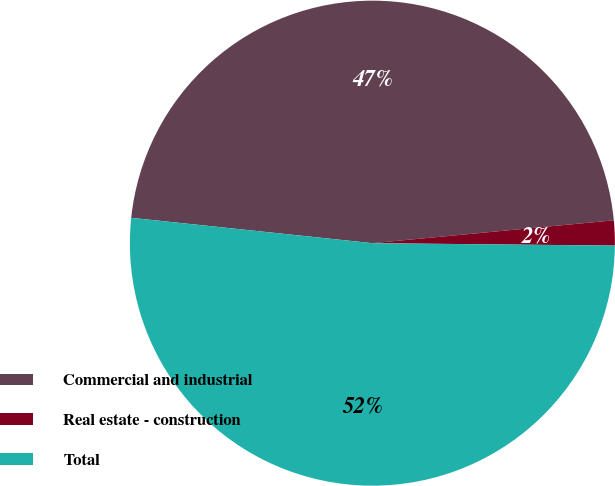Convert chart. <chart><loc_0><loc_0><loc_500><loc_500><pie_chart><fcel>Commercial and industrial<fcel>Real estate - construction<fcel>Total<nl><fcel>46.83%<fcel>1.66%<fcel>51.51%<nl></chart> 